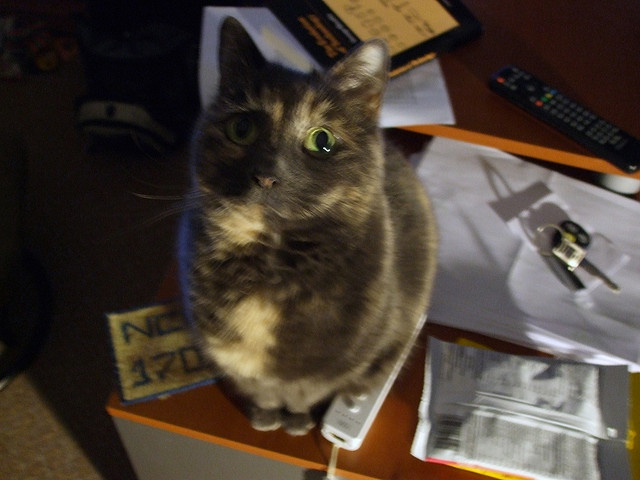Describe the objects in this image and their specific colors. I can see cat in black and gray tones, book in black and olive tones, remote in black, maroon, olive, and brown tones, and remote in black, darkgray, lightgray, and gray tones in this image. 